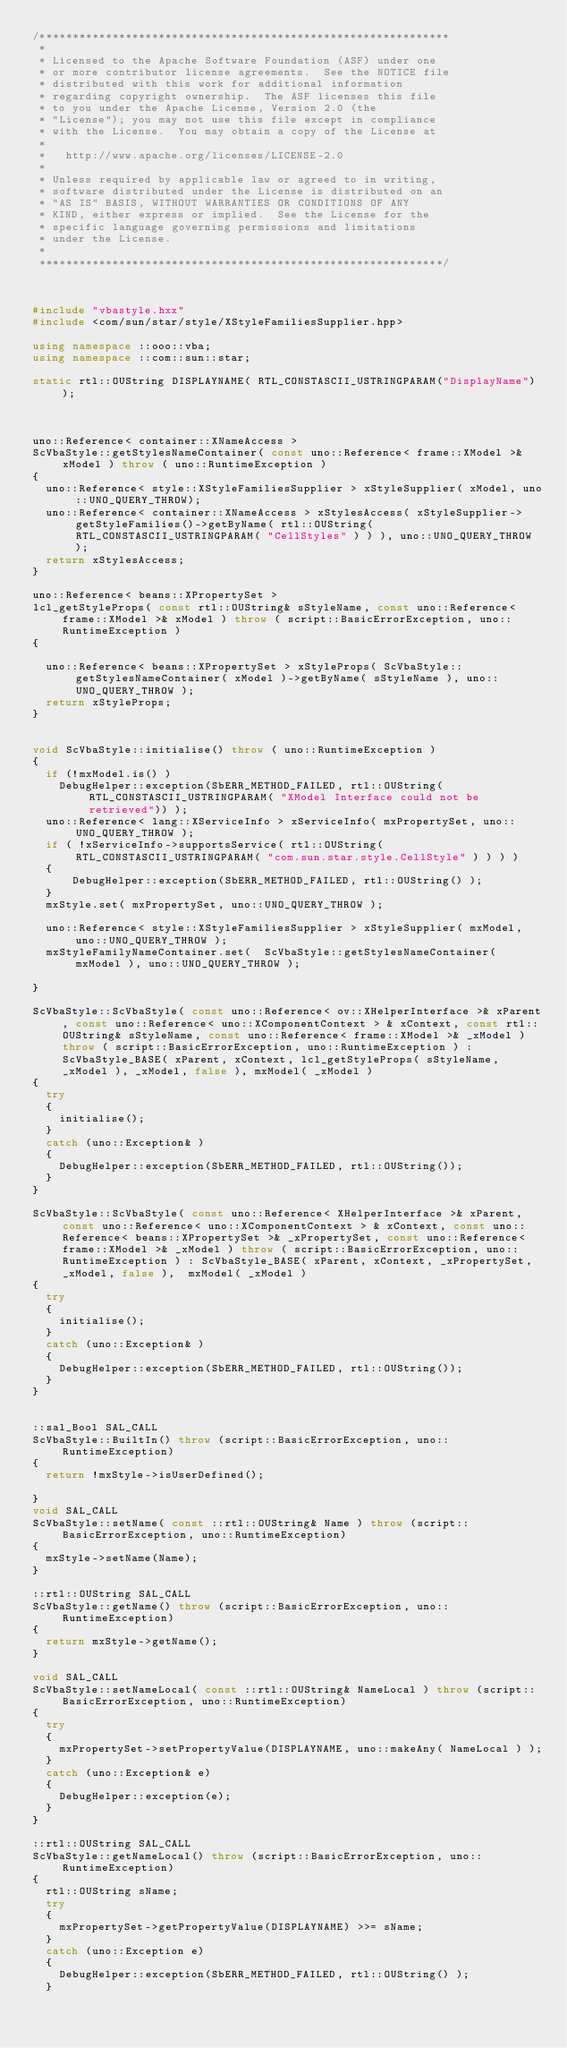Convert code to text. <code><loc_0><loc_0><loc_500><loc_500><_C++_>/**************************************************************
 * 
 * Licensed to the Apache Software Foundation (ASF) under one
 * or more contributor license agreements.  See the NOTICE file
 * distributed with this work for additional information
 * regarding copyright ownership.  The ASF licenses this file
 * to you under the Apache License, Version 2.0 (the
 * "License"); you may not use this file except in compliance
 * with the License.  You may obtain a copy of the License at
 * 
 *   http://www.apache.org/licenses/LICENSE-2.0
 * 
 * Unless required by applicable law or agreed to in writing,
 * software distributed under the License is distributed on an
 * "AS IS" BASIS, WITHOUT WARRANTIES OR CONDITIONS OF ANY
 * KIND, either express or implied.  See the License for the
 * specific language governing permissions and limitations
 * under the License.
 * 
 *************************************************************/



#include "vbastyle.hxx"
#include <com/sun/star/style/XStyleFamiliesSupplier.hpp>

using namespace ::ooo::vba;
using namespace ::com::sun::star;

static rtl::OUString DISPLAYNAME( RTL_CONSTASCII_USTRINGPARAM("DisplayName") );



uno::Reference< container::XNameAccess > 
ScVbaStyle::getStylesNameContainer( const uno::Reference< frame::XModel >& xModel ) throw ( uno::RuntimeException )
{
	uno::Reference< style::XStyleFamiliesSupplier > xStyleSupplier( xModel, uno::UNO_QUERY_THROW);
	uno::Reference< container::XNameAccess > xStylesAccess( xStyleSupplier->getStyleFamilies()->getByName( rtl::OUString( RTL_CONSTASCII_USTRINGPARAM( "CellStyles" ) ) ), uno::UNO_QUERY_THROW );
	return xStylesAccess;
}

uno::Reference< beans::XPropertySet > 
lcl_getStyleProps( const rtl::OUString& sStyleName, const uno::Reference< frame::XModel >& xModel ) throw ( script::BasicErrorException, uno::RuntimeException )
{
	
	uno::Reference< beans::XPropertySet > xStyleProps( ScVbaStyle::getStylesNameContainer( xModel )->getByName( sStyleName ), uno::UNO_QUERY_THROW );	
	return xStyleProps;
}


void ScVbaStyle::initialise() throw ( uno::RuntimeException )
{
	if (!mxModel.is() ) 
		DebugHelper::exception(SbERR_METHOD_FAILED, rtl::OUString( RTL_CONSTASCII_USTRINGPARAM( "XModel Interface could not be retrieved")) );                    
	uno::Reference< lang::XServiceInfo > xServiceInfo( mxPropertySet, uno::UNO_QUERY_THROW );
	if ( !xServiceInfo->supportsService( rtl::OUString( RTL_CONSTASCII_USTRINGPARAM( "com.sun.star.style.CellStyle" ) ) ) )
	{
			DebugHelper::exception(SbERR_METHOD_FAILED, rtl::OUString() );
	}
	mxStyle.set( mxPropertySet, uno::UNO_QUERY_THROW );
	
	uno::Reference< style::XStyleFamiliesSupplier > xStyleSupplier( mxModel, uno::UNO_QUERY_THROW );
	mxStyleFamilyNameContainer.set(  ScVbaStyle::getStylesNameContainer( mxModel ), uno::UNO_QUERY_THROW );

}

ScVbaStyle::ScVbaStyle( const uno::Reference< ov::XHelperInterface >& xParent, const uno::Reference< uno::XComponentContext > & xContext, const rtl::OUString& sStyleName, const uno::Reference< frame::XModel >& _xModel ) throw ( script::BasicErrorException, uno::RuntimeException ) :  ScVbaStyle_BASE( xParent, xContext, lcl_getStyleProps( sStyleName, _xModel ), _xModel, false ), mxModel( _xModel )
{
	try
	{
		initialise();
	}
	catch (uno::Exception& )
	{
		DebugHelper::exception(SbERR_METHOD_FAILED, rtl::OUString());
	}
}

ScVbaStyle::ScVbaStyle( const uno::Reference< XHelperInterface >& xParent, const uno::Reference< uno::XComponentContext > & xContext, const uno::Reference< beans::XPropertySet >& _xPropertySet, const uno::Reference< frame::XModel >& _xModel ) throw ( script::BasicErrorException, uno::RuntimeException ) : ScVbaStyle_BASE( xParent, xContext, _xPropertySet, _xModel, false ),  mxModel( _xModel )
{
	try
	{
		initialise();
	}
	catch (uno::Exception& )
	{
		DebugHelper::exception(SbERR_METHOD_FAILED, rtl::OUString());
	}
}


::sal_Bool SAL_CALL 
ScVbaStyle::BuiltIn() throw (script::BasicErrorException, uno::RuntimeException)
{
	return !mxStyle->isUserDefined();

}
void SAL_CALL 
ScVbaStyle::setName( const ::rtl::OUString& Name ) throw (script::BasicErrorException, uno::RuntimeException)
{
	mxStyle->setName(Name);
}

::rtl::OUString SAL_CALL 
ScVbaStyle::getName() throw (script::BasicErrorException, uno::RuntimeException)
{
	return mxStyle->getName();
}

void SAL_CALL 
ScVbaStyle::setNameLocal( const ::rtl::OUString& NameLocal ) throw (script::BasicErrorException, uno::RuntimeException)
{
	try
	{
		mxPropertySet->setPropertyValue(DISPLAYNAME, uno::makeAny( NameLocal ) );
	}
	catch (uno::Exception& e)
	{
		DebugHelper::exception(e);
	}
}

::rtl::OUString SAL_CALL 
ScVbaStyle::getNameLocal() throw (script::BasicErrorException, uno::RuntimeException)
{
	rtl::OUString sName;
	try
	{
		mxPropertySet->getPropertyValue(DISPLAYNAME) >>= sName;
	}
	catch (uno::Exception e)
	{
		DebugHelper::exception(SbERR_METHOD_FAILED, rtl::OUString() );
	}</code> 